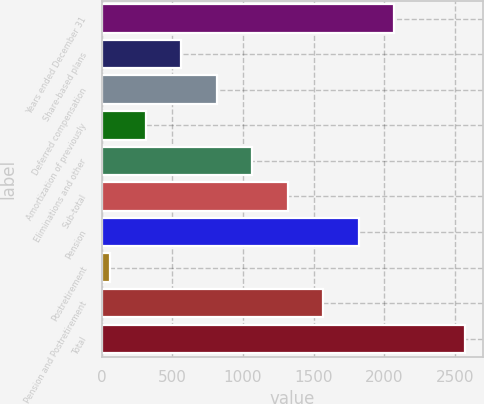Convert chart to OTSL. <chart><loc_0><loc_0><loc_500><loc_500><bar_chart><fcel>Years ended December 31<fcel>Share-based plans<fcel>Deferred compensation<fcel>Amortization of previously<fcel>Eliminations and other<fcel>Sub-total<fcel>Pension<fcel>Postretirement<fcel>Pension and Postretirement<fcel>Total<nl><fcel>2072<fcel>563<fcel>814.5<fcel>311.5<fcel>1066<fcel>1317.5<fcel>1820.5<fcel>60<fcel>1569<fcel>2575<nl></chart> 